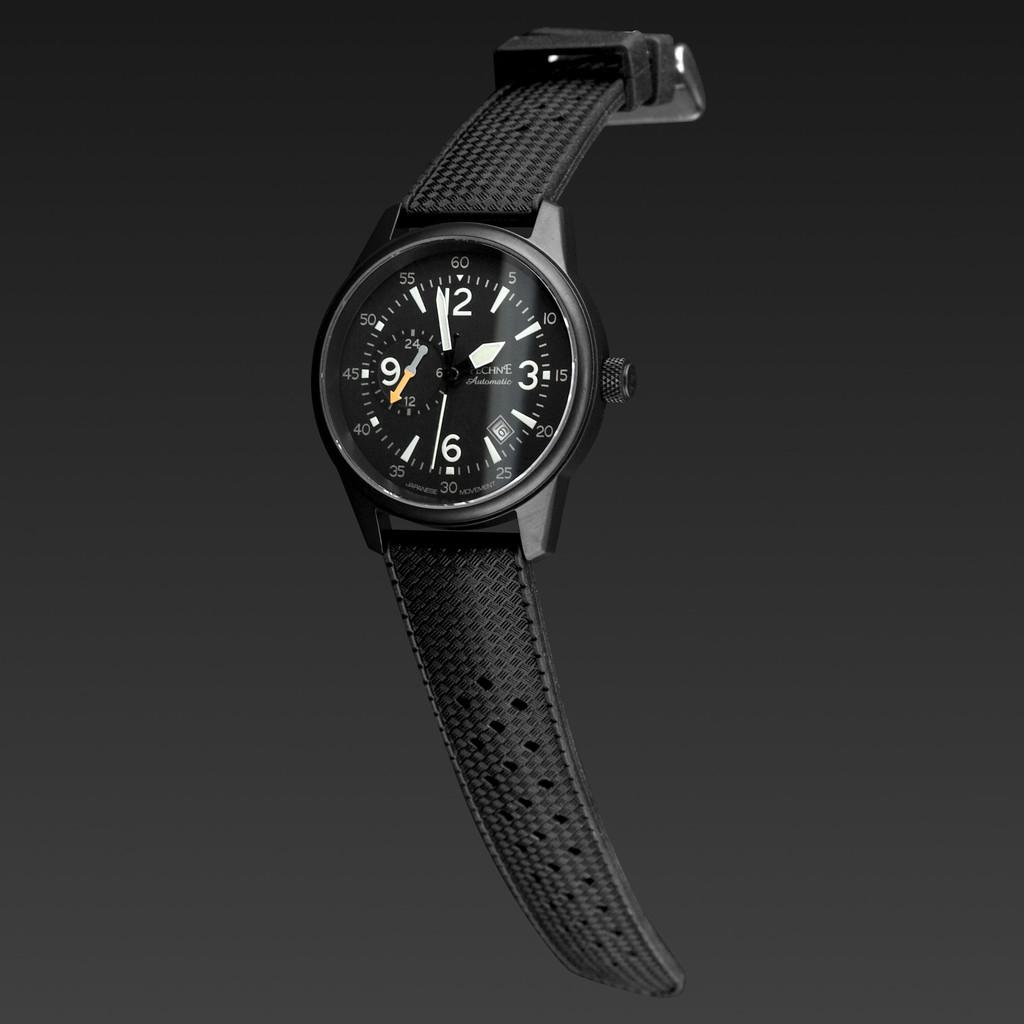<image>
Render a clear and concise summary of the photo. A black watch with a black strap shows it is nearly two o clock. 